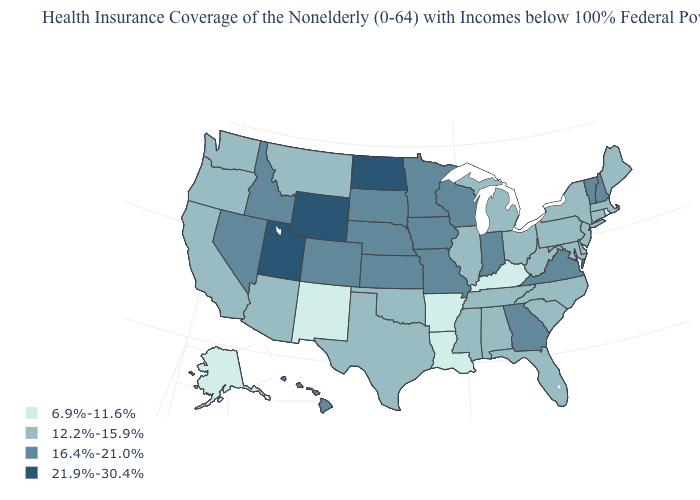Which states have the lowest value in the USA?
Concise answer only. Alaska, Arkansas, Kentucky, Louisiana, New Mexico, Rhode Island. What is the value of Pennsylvania?
Quick response, please. 12.2%-15.9%. Which states have the lowest value in the South?
Give a very brief answer. Arkansas, Kentucky, Louisiana. Among the states that border Louisiana , which have the highest value?
Give a very brief answer. Mississippi, Texas. How many symbols are there in the legend?
Give a very brief answer. 4. What is the highest value in the South ?
Short answer required. 16.4%-21.0%. Does Missouri have a higher value than Wyoming?
Write a very short answer. No. Does Louisiana have the lowest value in the USA?
Quick response, please. Yes. What is the value of Colorado?
Give a very brief answer. 16.4%-21.0%. Among the states that border Utah , does New Mexico have the highest value?
Quick response, please. No. Does Rhode Island have the highest value in the Northeast?
Short answer required. No. Name the states that have a value in the range 21.9%-30.4%?
Be succinct. North Dakota, Utah, Wyoming. Which states have the lowest value in the MidWest?
Be succinct. Illinois, Michigan, Ohio. Does California have the highest value in the USA?
Keep it brief. No. What is the lowest value in states that border Delaware?
Concise answer only. 12.2%-15.9%. 